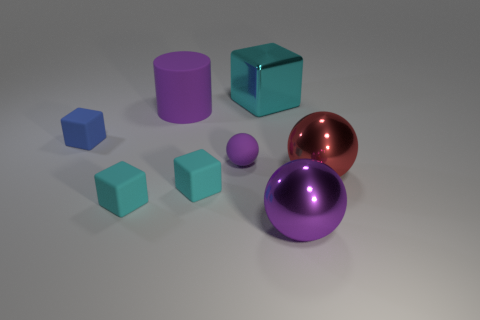What is the size of the metal sphere on the right side of the purple thing that is to the right of the small purple object?
Keep it short and to the point. Large. The cylinder that is the same color as the small sphere is what size?
Offer a terse response. Large. How many other things are there of the same size as the purple shiny thing?
Your answer should be very brief. 3. The metal thing in front of the matte block right of the purple object behind the blue matte cube is what color?
Your answer should be very brief. Purple. What number of other objects are the same shape as the big cyan shiny object?
Your answer should be very brief. 3. There is a purple thing on the right side of the tiny purple matte ball; what shape is it?
Make the answer very short. Sphere. Is there a small block behind the purple sphere behind the big red thing?
Give a very brief answer. Yes. There is a small thing that is both in front of the red shiny sphere and left of the big purple matte object; what color is it?
Offer a terse response. Cyan. Are there any purple balls in front of the purple thing in front of the big ball right of the large purple metallic thing?
Give a very brief answer. No. There is another purple object that is the same shape as the tiny purple object; what size is it?
Keep it short and to the point. Large. 